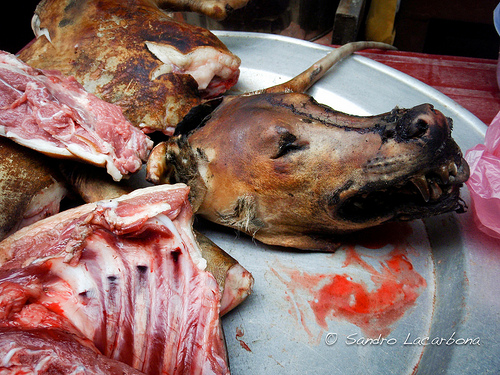<image>
Is the dog in the carry cover? No. The dog is not contained within the carry cover. These objects have a different spatial relationship. Is there a dog head in the plastic bag? No. The dog head is not contained within the plastic bag. These objects have a different spatial relationship. 